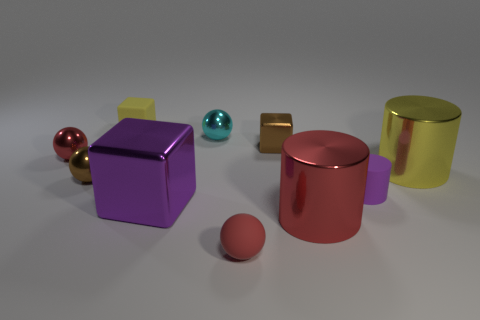Subtract 1 balls. How many balls are left? 3 Subtract all cylinders. How many objects are left? 7 Add 7 small red matte balls. How many small red matte balls are left? 8 Add 4 red rubber objects. How many red rubber objects exist? 5 Subtract 0 cyan blocks. How many objects are left? 10 Subtract all tiny green matte balls. Subtract all tiny rubber balls. How many objects are left? 9 